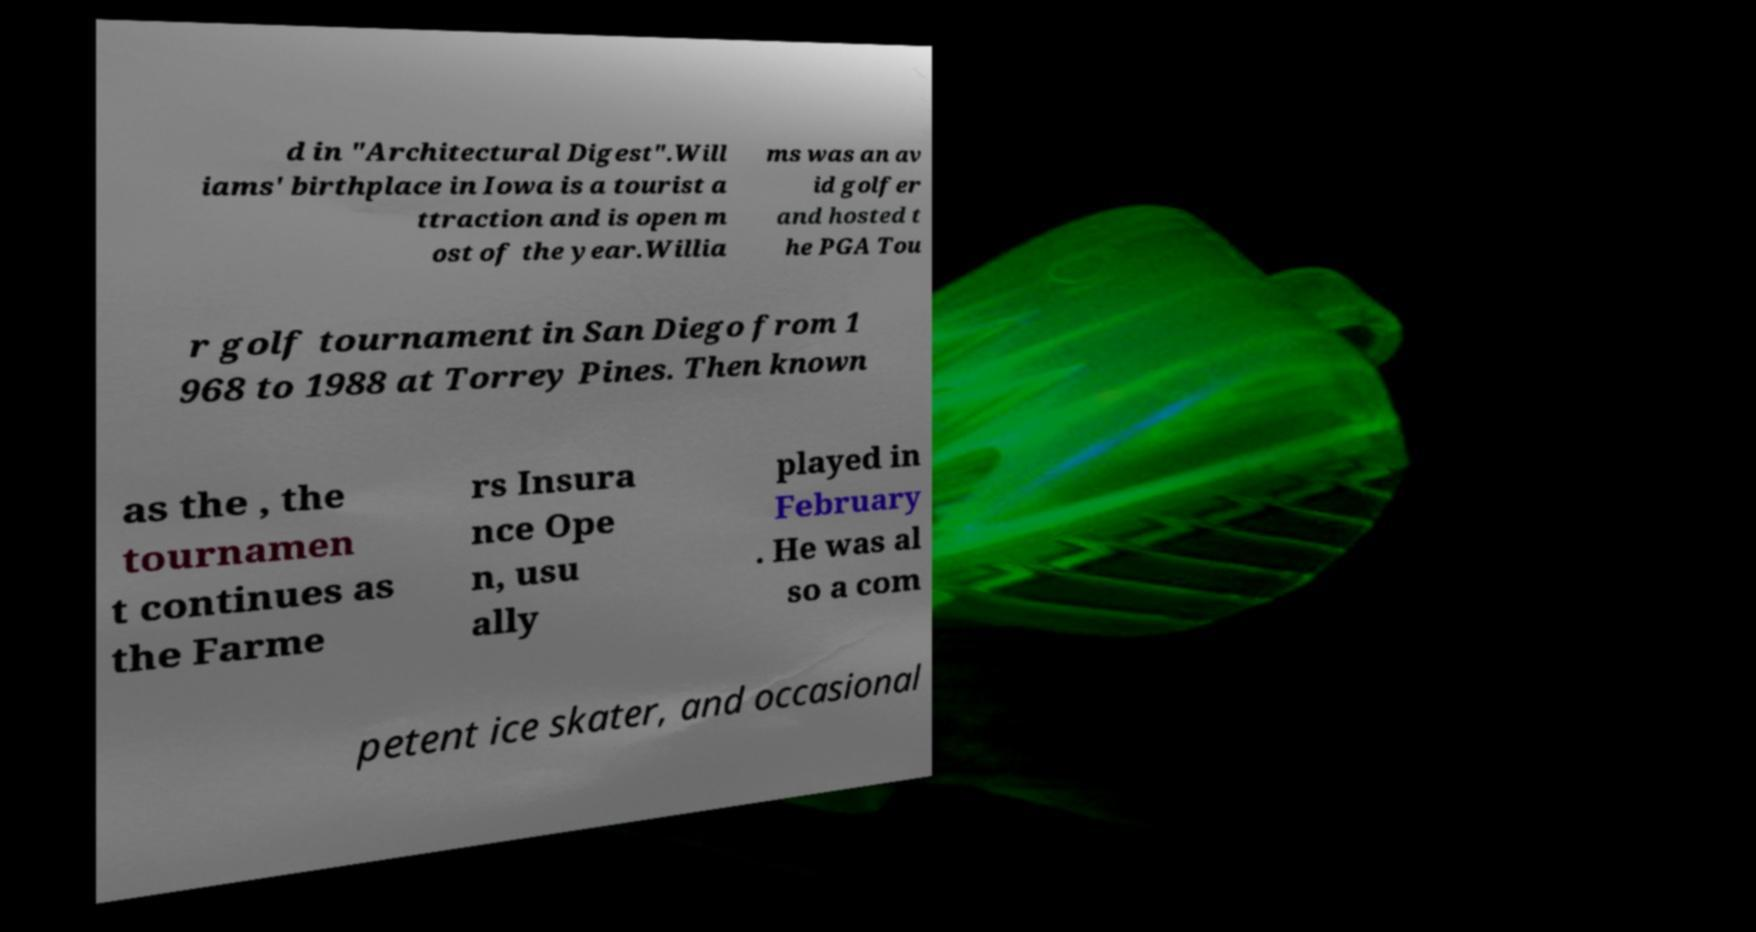Please identify and transcribe the text found in this image. d in "Architectural Digest".Will iams' birthplace in Iowa is a tourist a ttraction and is open m ost of the year.Willia ms was an av id golfer and hosted t he PGA Tou r golf tournament in San Diego from 1 968 to 1988 at Torrey Pines. Then known as the , the tournamen t continues as the Farme rs Insura nce Ope n, usu ally played in February . He was al so a com petent ice skater, and occasional 